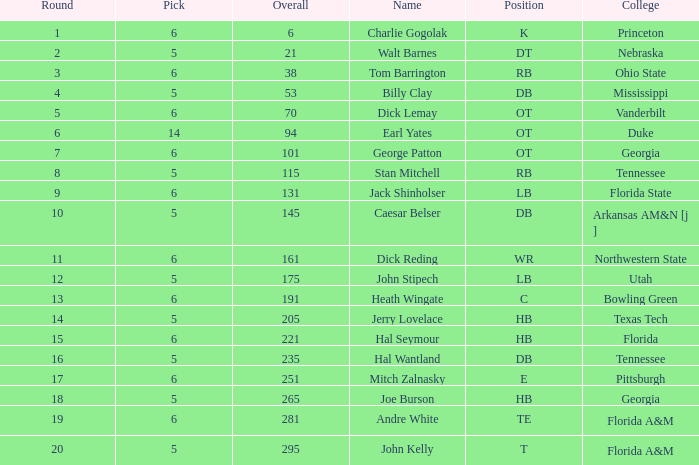What is the highest Pick, when Round is greater than 15, and when College is "Tennessee"? 5.0. 